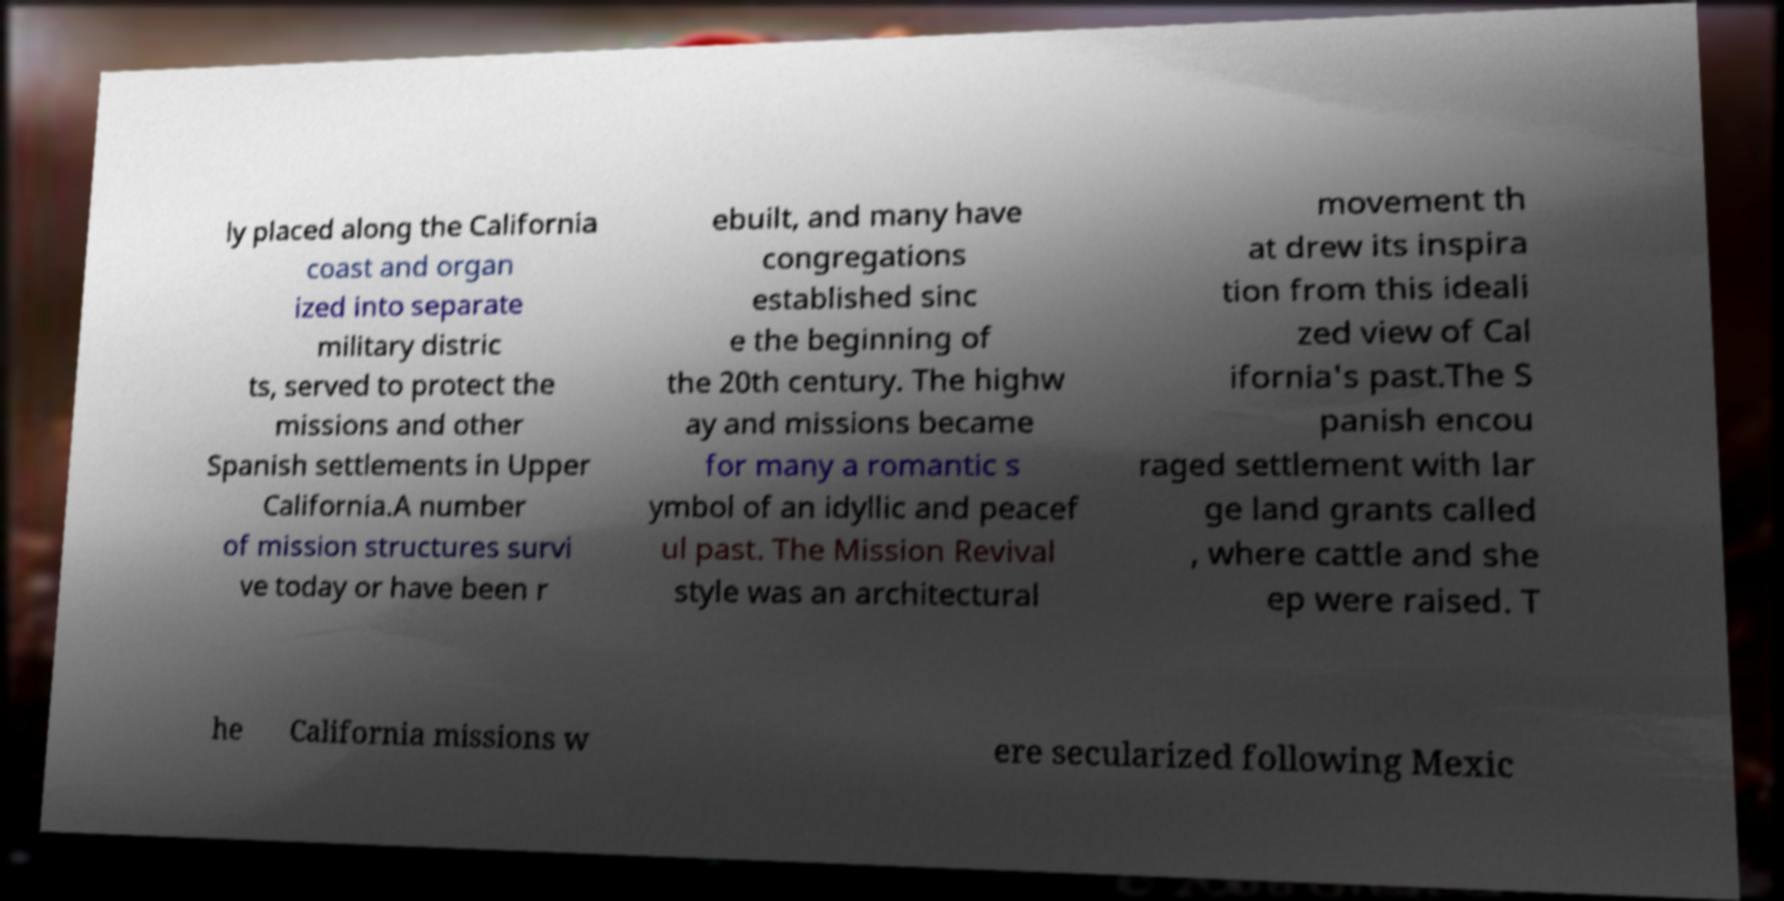I need the written content from this picture converted into text. Can you do that? ly placed along the California coast and organ ized into separate military distric ts, served to protect the missions and other Spanish settlements in Upper California.A number of mission structures survi ve today or have been r ebuilt, and many have congregations established sinc e the beginning of the 20th century. The highw ay and missions became for many a romantic s ymbol of an idyllic and peacef ul past. The Mission Revival style was an architectural movement th at drew its inspira tion from this ideali zed view of Cal ifornia's past.The S panish encou raged settlement with lar ge land grants called , where cattle and she ep were raised. T he California missions w ere secularized following Mexic 